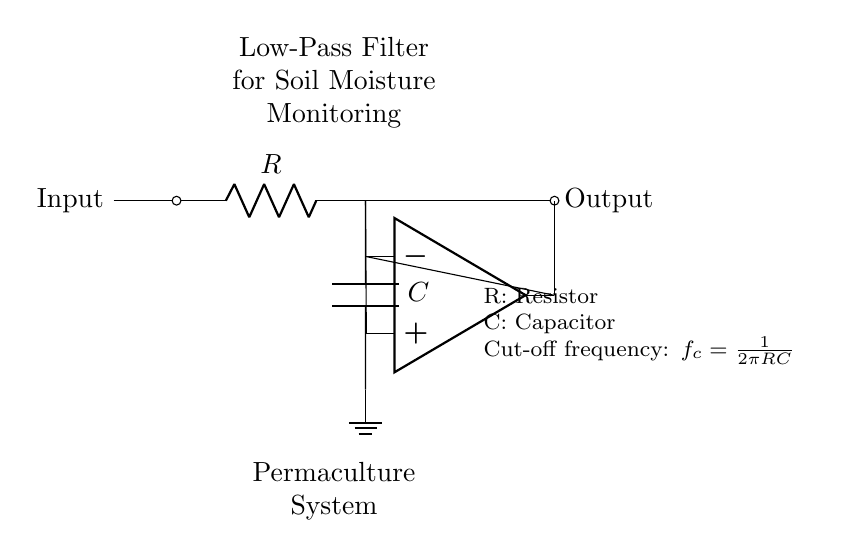What type of filter is represented in the circuit? The circuit is a low-pass filter, which allows low-frequency signals to pass through while attenuating high-frequency signals. This is indicated by the configuration of the resistor and capacitor in the circuit.
Answer: low-pass filter What does the capacitor in the circuit do? The capacitor acts as a frequency-dependent element that stores charge, allowing it to influence the cutoff frequency of the filter. In low-pass filters, the capacitor helps block high-frequency signals, while allowing low-frequency signals to pass through.
Answer: attenuates high frequencies What is the role of the resistor in this circuit? The resistor is used in conjunction with the capacitor to set the cutoff frequency of the low-pass filter. It helps determine how quickly the circuit responds to changes in input signal frequency.
Answer: sets cutoff frequency What is the cutoff frequency formula in this circuit? The cutoff frequency is given by the formula f_c = 1/(2πRC), where R is the resistance and C is the capacitance. This formula indicates how the cutoff frequency changes based on the values of R and C, affecting the filter's performance.
Answer: f_c = 1/(2πRC) What happens to the output signal if high-frequency noise is present? The output signal will experience significant attenuation since the low-pass filter is designed to reduce the amplitude of high-frequency signals, allowing primarily low-frequency components (like soil moisture level signals) to be observed in the output.
Answer: output attenuates high-frequency noise How can you change the cutoff frequency of this filter? The cutoff frequency can be changed by modifying the values of the resistor (R) or the capacitor (C) in the circuit. Increasing R or C will lower the cutoff frequency, while decreasing them will raise the cutoff frequency.
Answer: modify resistor or capacitor values 